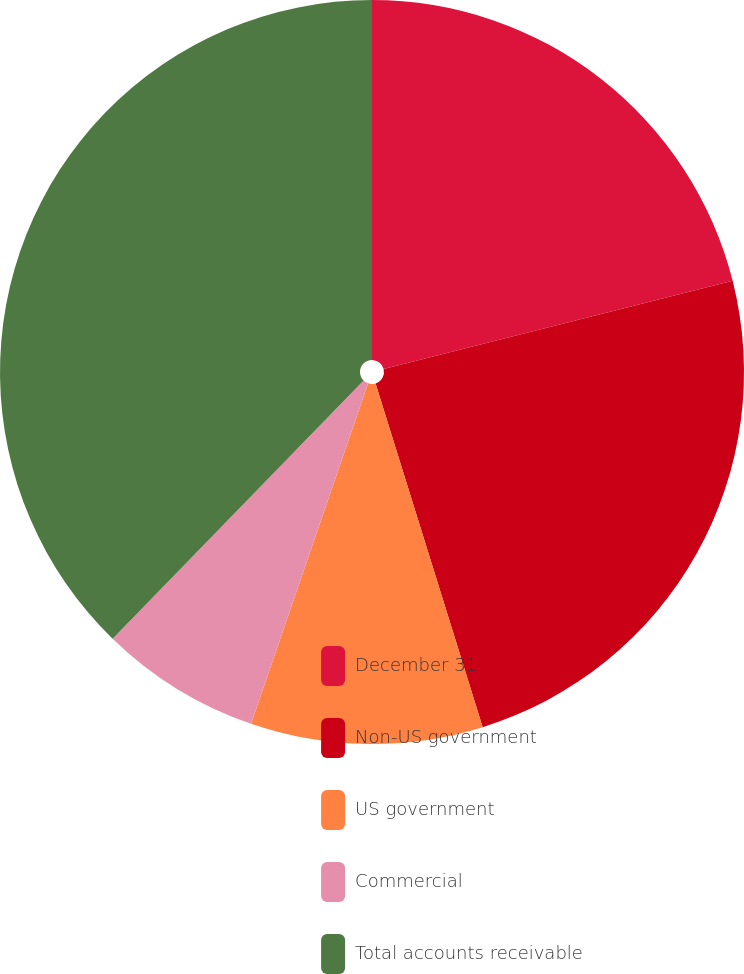Convert chart to OTSL. <chart><loc_0><loc_0><loc_500><loc_500><pie_chart><fcel>December 31<fcel>Non-US government<fcel>US government<fcel>Commercial<fcel>Total accounts receivable<nl><fcel>21.06%<fcel>24.13%<fcel>10.08%<fcel>7.01%<fcel>37.72%<nl></chart> 